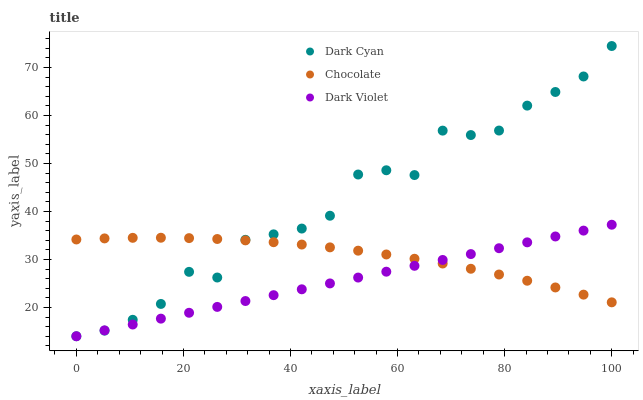Does Dark Violet have the minimum area under the curve?
Answer yes or no. Yes. Does Dark Cyan have the maximum area under the curve?
Answer yes or no. Yes. Does Chocolate have the minimum area under the curve?
Answer yes or no. No. Does Chocolate have the maximum area under the curve?
Answer yes or no. No. Is Dark Violet the smoothest?
Answer yes or no. Yes. Is Dark Cyan the roughest?
Answer yes or no. Yes. Is Chocolate the smoothest?
Answer yes or no. No. Is Chocolate the roughest?
Answer yes or no. No. Does Dark Cyan have the lowest value?
Answer yes or no. Yes. Does Chocolate have the lowest value?
Answer yes or no. No. Does Dark Cyan have the highest value?
Answer yes or no. Yes. Does Dark Violet have the highest value?
Answer yes or no. No. Does Dark Cyan intersect Chocolate?
Answer yes or no. Yes. Is Dark Cyan less than Chocolate?
Answer yes or no. No. Is Dark Cyan greater than Chocolate?
Answer yes or no. No. 